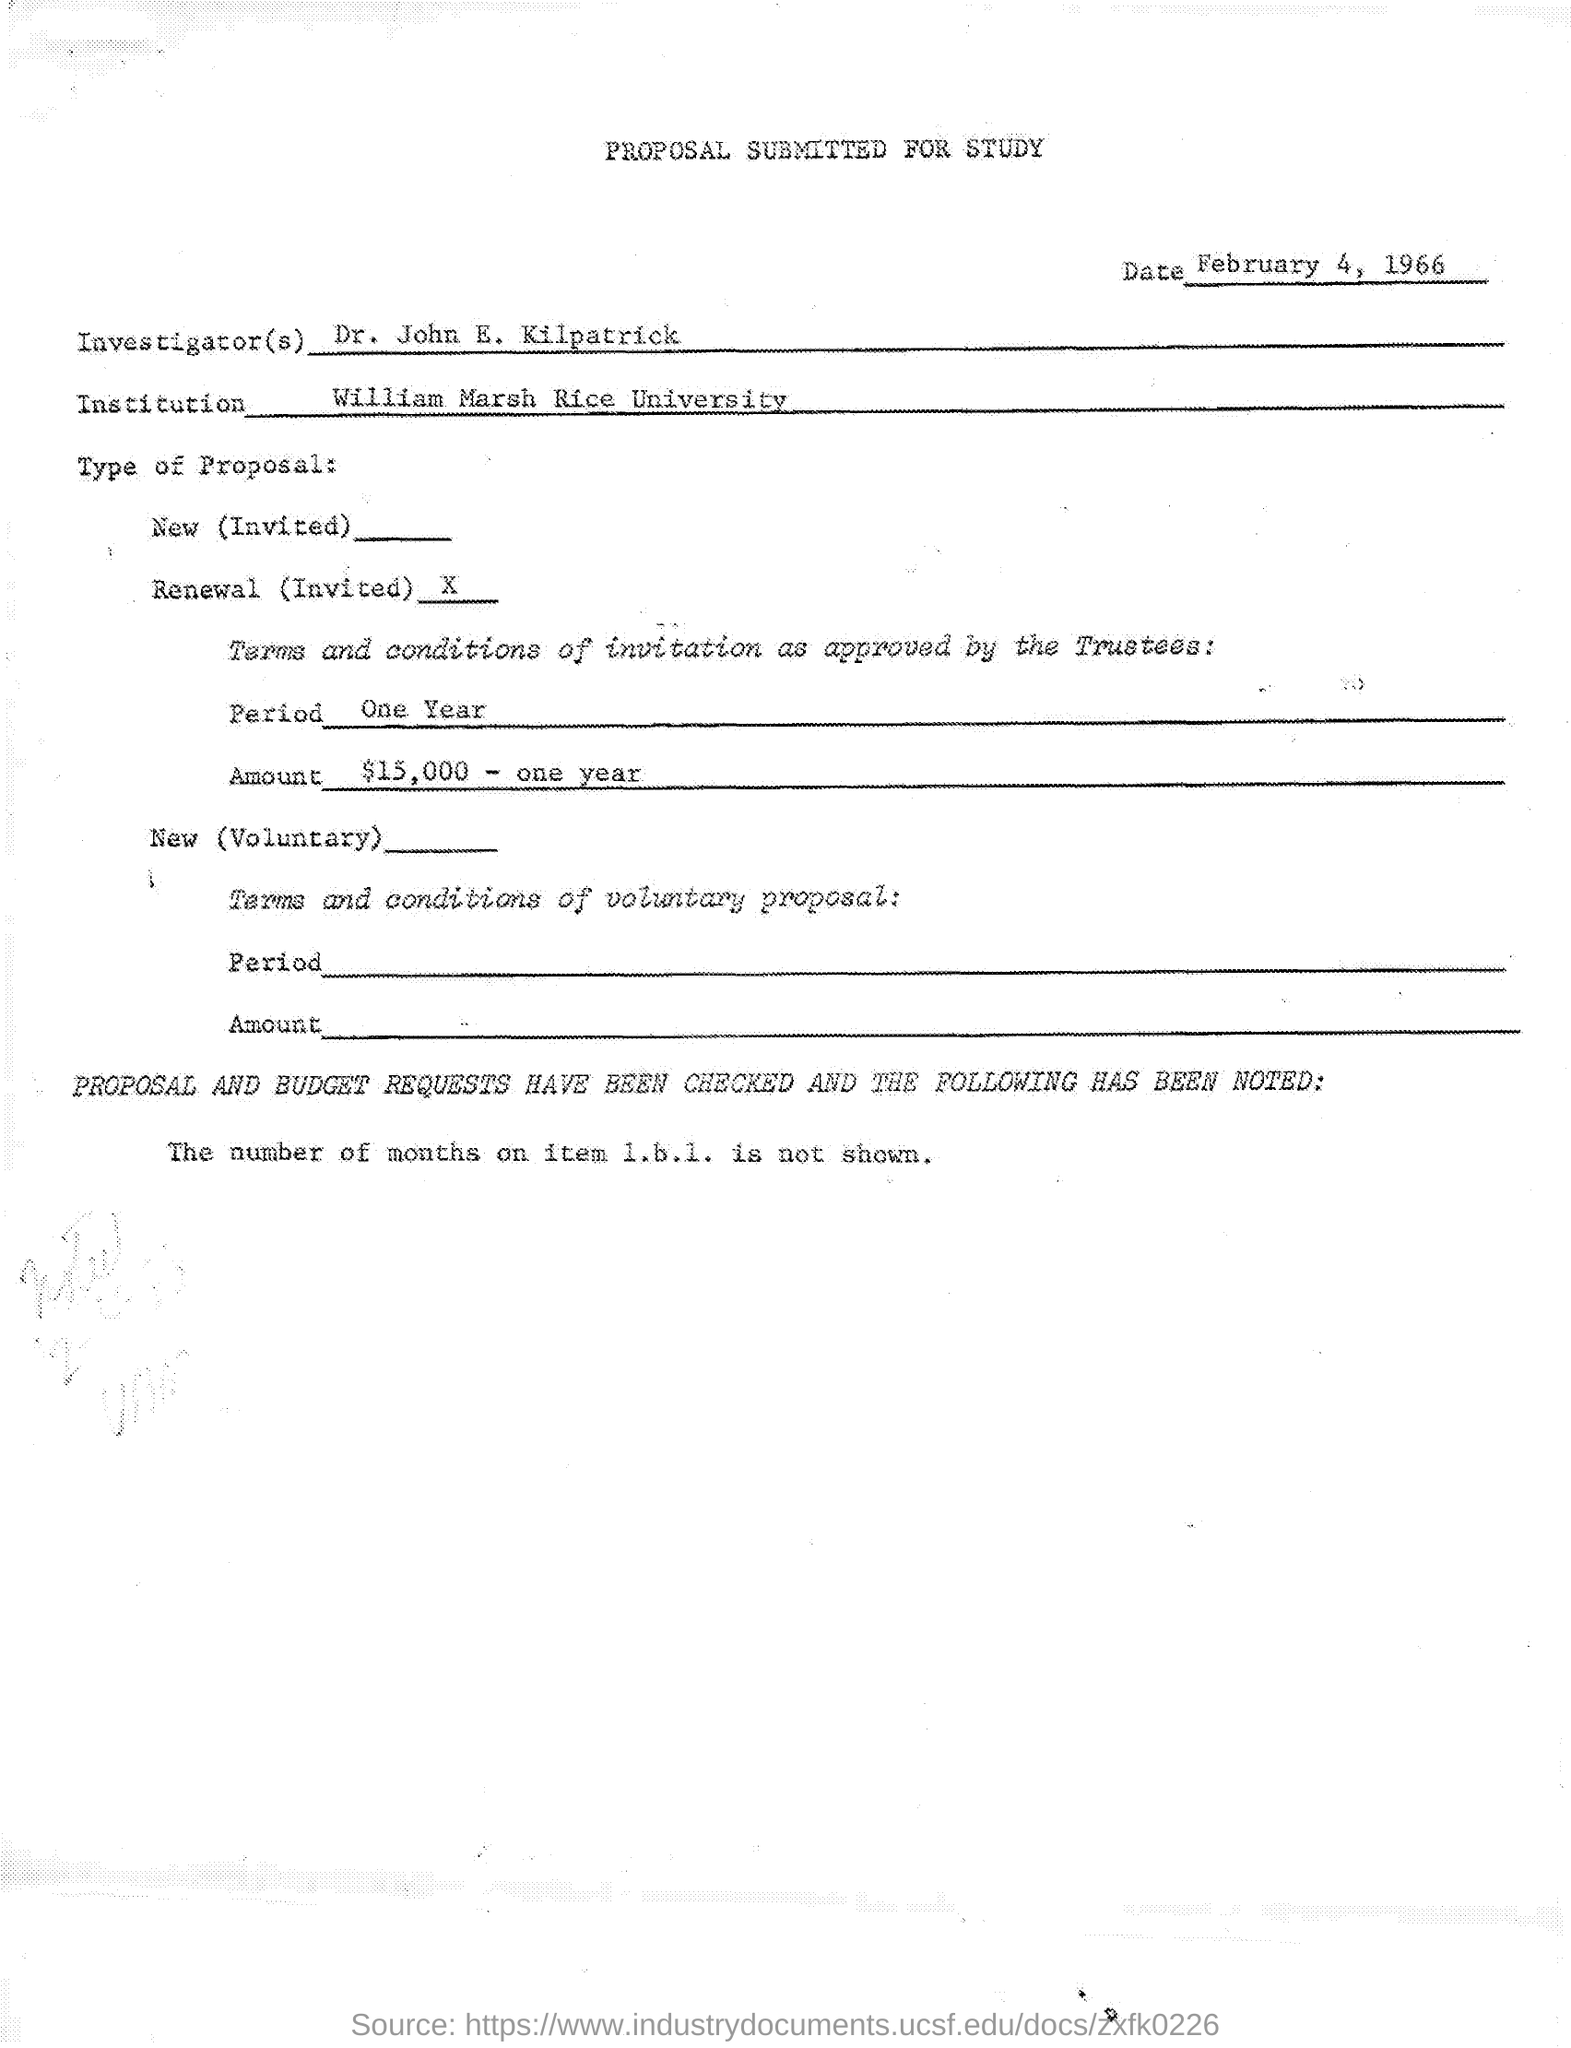Draw attention to some important aspects in this diagram. The date is February 4, 1966. The period is one year. William Marsh Rice University is an institution located in the United States. The person identified as "the Investigator" is Dr. John E. Kilpatrick. The title of the document is a proposal submitted for study. 